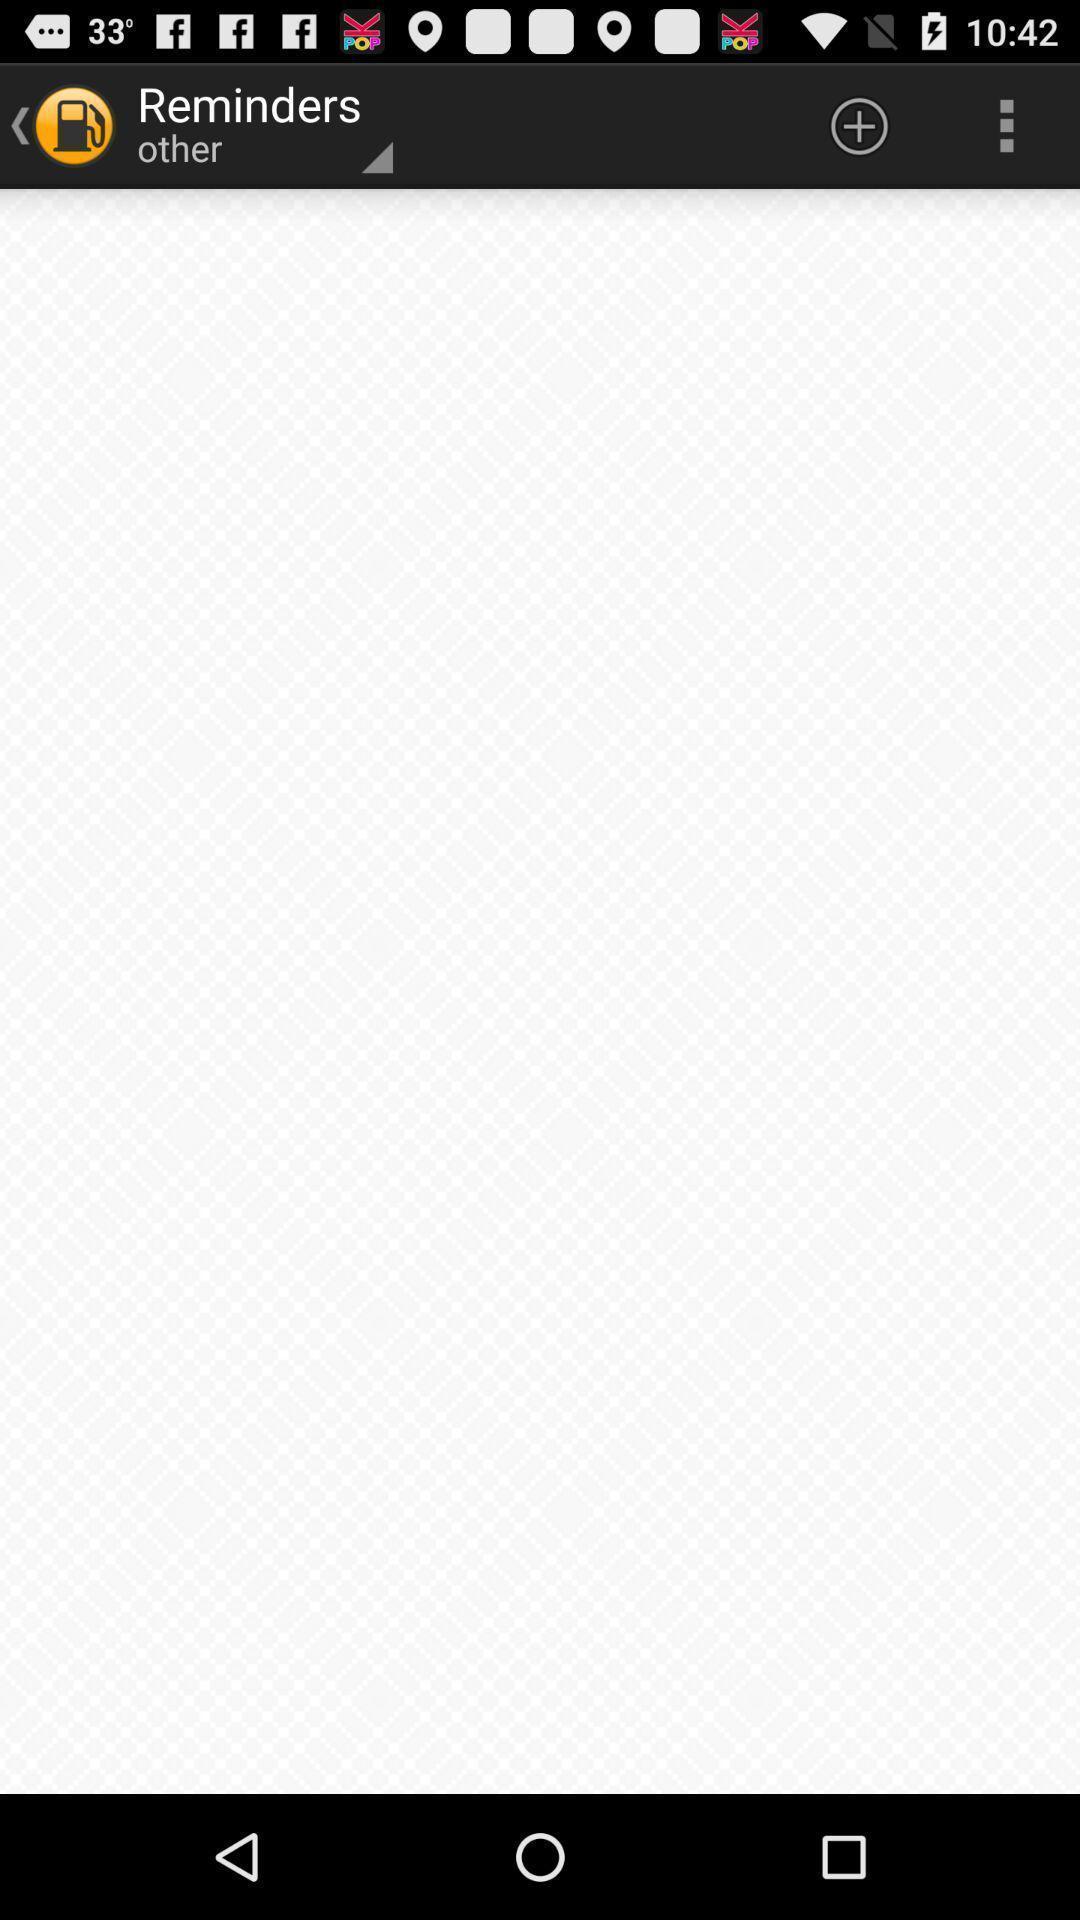Tell me what you see in this picture. Page showing reminders as empty. 